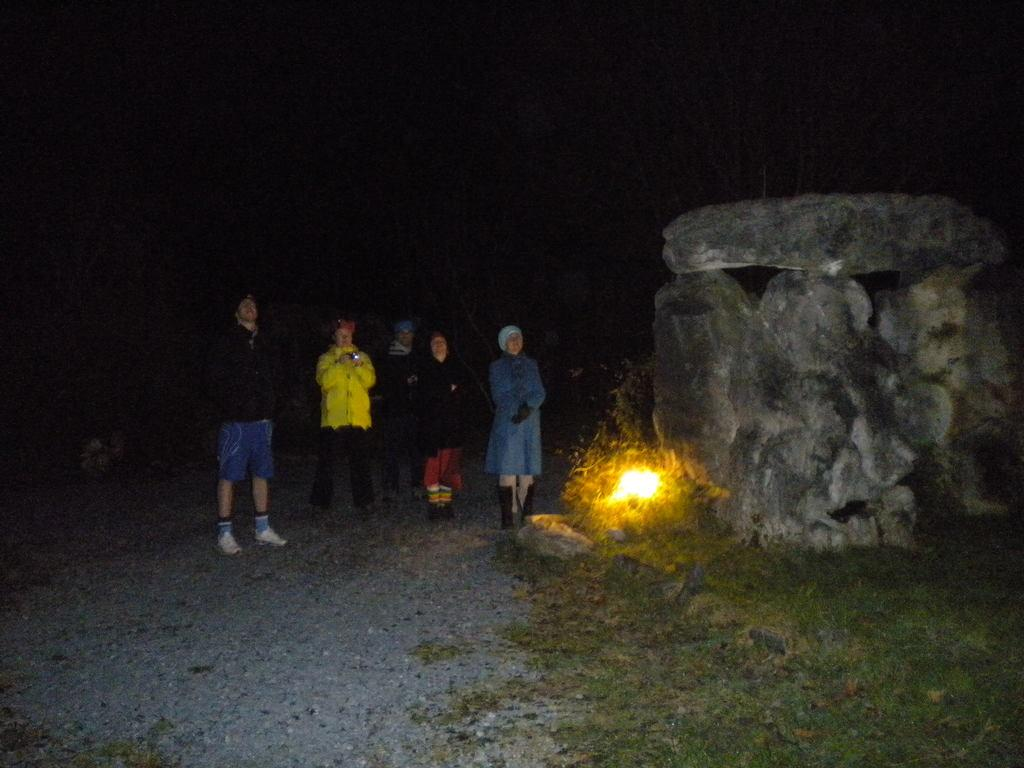Who or what can be seen in the image? There are people in the image. What type of terrain is visible in the image? There is green grass in the image. What is the source of illumination in the image? There is light in the image. What can be seen in the distance in the image? There are rocks in the background of the image. What type of window is visible in the image? There is no window present in the image. What kind of offer can be seen being made by the people in the image? There is no offer being made by the people in the image; they are simply present in the scene. 